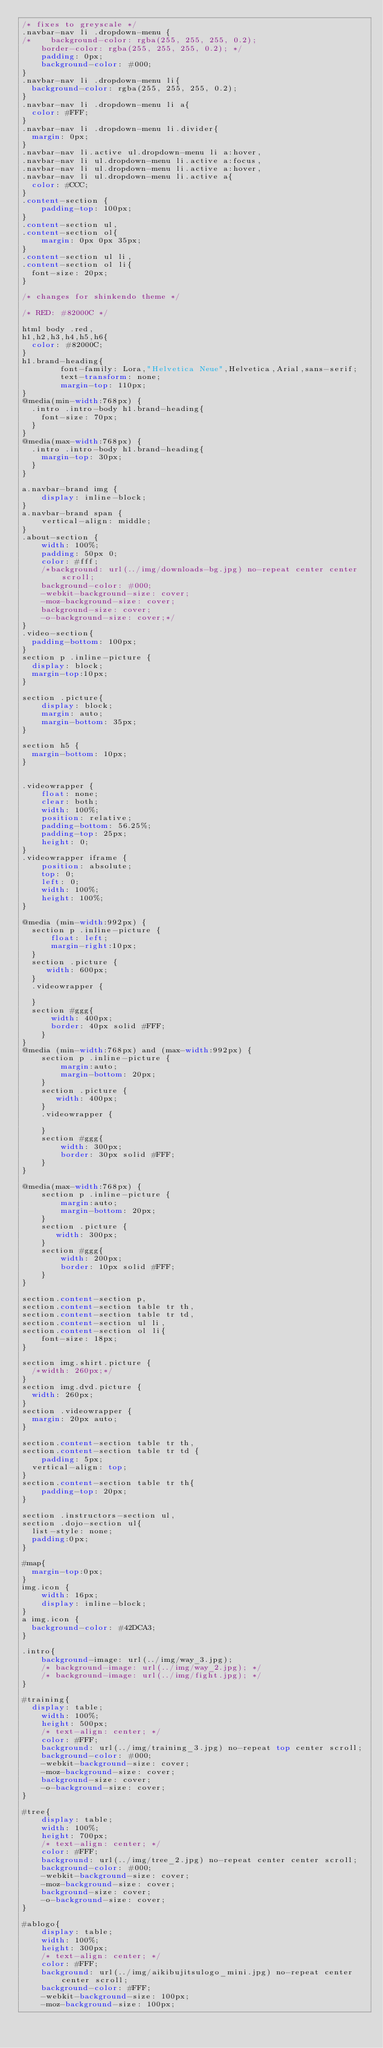<code> <loc_0><loc_0><loc_500><loc_500><_CSS_>/* fixes to greyscale */
.navbar-nav li .dropdown-menu {
/*    background-color: rgba(255, 255, 255, 0.2);
    border-color: rgba(255, 255, 255, 0.2); */
    padding: 0px;
    background-color: #000;
}
.navbar-nav li .dropdown-menu li{
	background-color: rgba(255, 255, 255, 0.2);
}
.navbar-nav li .dropdown-menu li a{
	color: #FFF;
}
.navbar-nav li .dropdown-menu li.divider{
	margin: 0px;
}
.navbar-nav li.active ul.dropdown-menu li a:hover,
.navbar-nav li ul.dropdown-menu li.active a:focus,
.navbar-nav li ul.dropdown-menu li.active a:hover,
.navbar-nav li ul.dropdown-menu li.active a{
	color: #CCC;
}
.content-section {
    padding-top: 100px;
}
.content-section ul,
.content-section ol{
    margin: 0px 0px 35px;
}
.content-section ul li,
.content-section ol li{
	font-size: 20px;
}

/* changes for shinkendo theme */

/* RED: #82000C */

html body .red,
h1,h2,h3,h4,h5,h6{
	color: #82000C;
}
h1.brand-heading{
        font-family: Lora,"Helvetica Neue",Helvetica,Arial,sans-serif;
        text-transform: none;
        margin-top: 110px;
}
@media(min-width:768px) {
	.intro .intro-body h1.brand-heading{
		font-size: 70px;
	}
}
@media(max-width:768px) {
	.intro .intro-body h1.brand-heading{
		margin-top: 30px;
	}
}

a.navbar-brand img {
    display: inline-block;
}
a.navbar-brand span {
    vertical-align: middle;
}
.about-section {
    width: 100%;
    padding: 50px 0;
    color: #fff;
    /*background: url(../img/downloads-bg.jpg) no-repeat center center scroll;
    background-color: #000;
    -webkit-background-size: cover;
    -moz-background-size: cover;
    background-size: cover;
    -o-background-size: cover;*/
}
.video-section{
	padding-bottom: 100px;
}
section p .inline-picture {
	display: block;
	margin-top:10px;
}

section .picture{
    display: block;
    margin: auto;
    margin-bottom: 35px;
}

section h5 {
	margin-bottom: 10px;
}


.videowrapper {
    float: none;
    clear: both;
    width: 100%;
    position: relative;
    padding-bottom: 56.25%;
    padding-top: 25px;
    height: 0;
}
.videowrapper iframe {
    position: absolute;
    top: 0;
    left: 0;
    width: 100%;
    height: 100%;
}

@media (min-width:992px) {
	section p .inline-picture {
	    float: left;
	    margin-right:10px;
	}
	section .picture {
	   width: 600px;
	}
	.videowrapper {

	}
	section #ggg{
	    width: 400px;
	    border: 40px solid #FFF;
    }
}
@media (min-width:768px) and (max-width:992px) {
    section p .inline-picture {
        margin:auto;
        margin-bottom: 20px;
    }
    section .picture {
       width: 400px;
    }
    .videowrapper {

    }
    section #ggg{
        width: 300px;
        border: 30px solid #FFF;
    }
}

@media(max-width:768px) {
    section p .inline-picture {
        margin:auto;
        margin-bottom: 20px;
    }
    section .picture {
       width: 300px;
    }
    section #ggg{
        width: 200px;
        border: 10px solid #FFF;
    }
}

section.content-section p,
section.content-section table tr th,
section.content-section table tr td,
section.content-section ul li,
section.content-section ol li{
    font-size: 18px;
}

section img.shirt.picture {
	/*width: 260px;*/
}
section img.dvd.picture {
	width: 260px;
}
section .videowrapper {
	margin: 20px auto;
}

section.content-section table tr th,
section.content-section table tr td {
    padding: 5px;
	vertical-align: top;
}
section.content-section table tr th{
    padding-top: 20px;
}

section .instructors-section ul,
section .dojo-section ul{
	list-style: none;
	padding:0px;
}

#map{
	margin-top:0px;
}
img.icon {
    width: 16px;
    display: inline-block;
}
a img.icon {
  background-color: #42DCA3;
}

.intro{
    background-image: url(../img/way_3.jpg);
    /* background-image: url(../img/way_2.jpg); */
    /* background-image: url(../img/fight.jpg); */
}

#training{
	display: table;
    width: 100%;
    height: 500px;
    /* text-align: center; */
    color: #FFF;
    background: url(../img/training_3.jpg) no-repeat top center scroll;
    background-color: #000;
    -webkit-background-size: cover;
    -moz-background-size: cover;
    background-size: cover;
    -o-background-size: cover;
}

#tree{
    display: table;
    width: 100%;
    height: 700px;
    /* text-align: center; */
    color: #FFF;
    background: url(../img/tree_2.jpg) no-repeat center center scroll;
    background-color: #000;
    -webkit-background-size: cover;
    -moz-background-size: cover;
    background-size: cover;
    -o-background-size: cover;
}

#ablogo{
    display: table;
    width: 100%;
    height: 300px;
    /* text-align: center; */
    color: #FFF;
    background: url(../img/aikibujitsulogo_mini.jpg) no-repeat center center scroll;
    background-color: #FFF;
    -webkit-background-size: 100px;
    -moz-background-size: 100px;</code> 